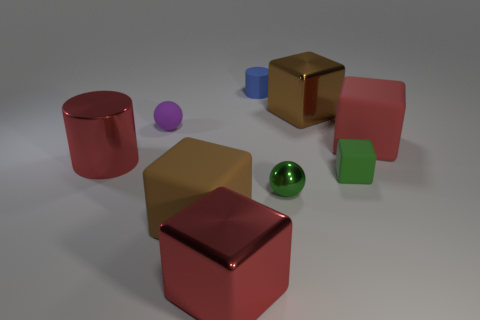Subtract all brown rubber blocks. How many blocks are left? 4 Add 6 small gray metal objects. How many small gray metal objects exist? 6 Subtract all brown blocks. How many blocks are left? 3 Subtract 0 yellow balls. How many objects are left? 9 Subtract all blocks. How many objects are left? 4 Subtract 2 cylinders. How many cylinders are left? 0 Subtract all yellow blocks. Subtract all cyan balls. How many blocks are left? 5 Subtract all cyan cubes. How many purple cylinders are left? 0 Subtract all big red objects. Subtract all green blocks. How many objects are left? 5 Add 6 purple balls. How many purple balls are left? 7 